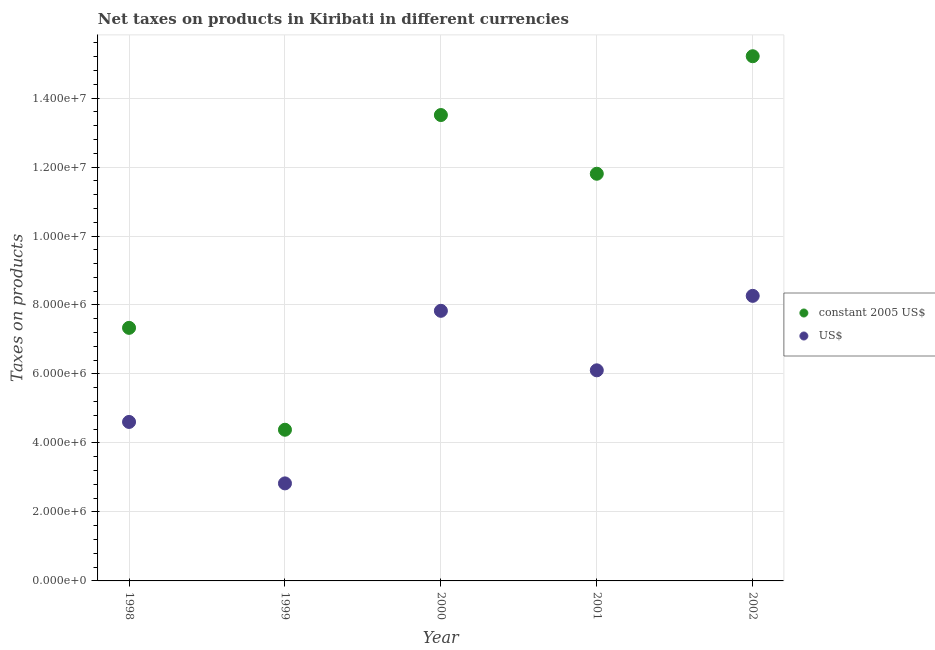How many different coloured dotlines are there?
Your answer should be very brief. 2. Is the number of dotlines equal to the number of legend labels?
Provide a succinct answer. Yes. What is the net taxes in us$ in 2001?
Your answer should be very brief. 6.11e+06. Across all years, what is the maximum net taxes in us$?
Provide a succinct answer. 8.26e+06. Across all years, what is the minimum net taxes in us$?
Offer a very short reply. 2.83e+06. What is the total net taxes in us$ in the graph?
Give a very brief answer. 2.96e+07. What is the difference between the net taxes in constant 2005 us$ in 1998 and that in 2002?
Give a very brief answer. -7.88e+06. What is the difference between the net taxes in us$ in 2001 and the net taxes in constant 2005 us$ in 1999?
Give a very brief answer. 1.72e+06. What is the average net taxes in us$ per year?
Ensure brevity in your answer.  5.93e+06. In the year 2001, what is the difference between the net taxes in us$ and net taxes in constant 2005 us$?
Ensure brevity in your answer.  -5.70e+06. What is the ratio of the net taxes in us$ in 1998 to that in 2000?
Ensure brevity in your answer.  0.59. What is the difference between the highest and the second highest net taxes in constant 2005 us$?
Offer a very short reply. 1.70e+06. What is the difference between the highest and the lowest net taxes in constant 2005 us$?
Offer a very short reply. 1.08e+07. In how many years, is the net taxes in constant 2005 us$ greater than the average net taxes in constant 2005 us$ taken over all years?
Your response must be concise. 3. Is the sum of the net taxes in us$ in 2000 and 2001 greater than the maximum net taxes in constant 2005 us$ across all years?
Make the answer very short. No. Is the net taxes in us$ strictly less than the net taxes in constant 2005 us$ over the years?
Provide a succinct answer. Yes. How many dotlines are there?
Offer a very short reply. 2. What is the difference between two consecutive major ticks on the Y-axis?
Your answer should be compact. 2.00e+06. Are the values on the major ticks of Y-axis written in scientific E-notation?
Keep it short and to the point. Yes. Does the graph contain any zero values?
Your answer should be compact. No. How many legend labels are there?
Your answer should be very brief. 2. How are the legend labels stacked?
Give a very brief answer. Vertical. What is the title of the graph?
Ensure brevity in your answer.  Net taxes on products in Kiribati in different currencies. Does "Forest land" appear as one of the legend labels in the graph?
Offer a terse response. No. What is the label or title of the X-axis?
Give a very brief answer. Year. What is the label or title of the Y-axis?
Your response must be concise. Taxes on products. What is the Taxes on products in constant 2005 US$ in 1998?
Provide a short and direct response. 7.34e+06. What is the Taxes on products of US$ in 1998?
Ensure brevity in your answer.  4.61e+06. What is the Taxes on products of constant 2005 US$ in 1999?
Ensure brevity in your answer.  4.38e+06. What is the Taxes on products of US$ in 1999?
Offer a very short reply. 2.83e+06. What is the Taxes on products in constant 2005 US$ in 2000?
Provide a short and direct response. 1.35e+07. What is the Taxes on products in US$ in 2000?
Your answer should be very brief. 7.83e+06. What is the Taxes on products in constant 2005 US$ in 2001?
Your answer should be compact. 1.18e+07. What is the Taxes on products in US$ in 2001?
Provide a succinct answer. 6.11e+06. What is the Taxes on products in constant 2005 US$ in 2002?
Offer a terse response. 1.52e+07. What is the Taxes on products in US$ in 2002?
Your answer should be very brief. 8.26e+06. Across all years, what is the maximum Taxes on products of constant 2005 US$?
Make the answer very short. 1.52e+07. Across all years, what is the maximum Taxes on products in US$?
Keep it short and to the point. 8.26e+06. Across all years, what is the minimum Taxes on products in constant 2005 US$?
Offer a terse response. 4.38e+06. Across all years, what is the minimum Taxes on products of US$?
Offer a very short reply. 2.83e+06. What is the total Taxes on products in constant 2005 US$ in the graph?
Ensure brevity in your answer.  5.22e+07. What is the total Taxes on products of US$ in the graph?
Make the answer very short. 2.96e+07. What is the difference between the Taxes on products in constant 2005 US$ in 1998 and that in 1999?
Ensure brevity in your answer.  2.95e+06. What is the difference between the Taxes on products in US$ in 1998 and that in 1999?
Offer a terse response. 1.78e+06. What is the difference between the Taxes on products in constant 2005 US$ in 1998 and that in 2000?
Your answer should be very brief. -6.17e+06. What is the difference between the Taxes on products of US$ in 1998 and that in 2000?
Give a very brief answer. -3.22e+06. What is the difference between the Taxes on products in constant 2005 US$ in 1998 and that in 2001?
Offer a very short reply. -4.47e+06. What is the difference between the Taxes on products of US$ in 1998 and that in 2001?
Your response must be concise. -1.50e+06. What is the difference between the Taxes on products in constant 2005 US$ in 1998 and that in 2002?
Ensure brevity in your answer.  -7.88e+06. What is the difference between the Taxes on products in US$ in 1998 and that in 2002?
Provide a short and direct response. -3.66e+06. What is the difference between the Taxes on products of constant 2005 US$ in 1999 and that in 2000?
Your answer should be very brief. -9.12e+06. What is the difference between the Taxes on products in US$ in 1999 and that in 2000?
Make the answer very short. -5.00e+06. What is the difference between the Taxes on products of constant 2005 US$ in 1999 and that in 2001?
Your answer should be compact. -7.42e+06. What is the difference between the Taxes on products of US$ in 1999 and that in 2001?
Make the answer very short. -3.28e+06. What is the difference between the Taxes on products in constant 2005 US$ in 1999 and that in 2002?
Your answer should be compact. -1.08e+07. What is the difference between the Taxes on products of US$ in 1999 and that in 2002?
Offer a very short reply. -5.44e+06. What is the difference between the Taxes on products in constant 2005 US$ in 2000 and that in 2001?
Provide a succinct answer. 1.70e+06. What is the difference between the Taxes on products in US$ in 2000 and that in 2001?
Provide a short and direct response. 1.73e+06. What is the difference between the Taxes on products in constant 2005 US$ in 2000 and that in 2002?
Offer a terse response. -1.70e+06. What is the difference between the Taxes on products of US$ in 2000 and that in 2002?
Your answer should be very brief. -4.34e+05. What is the difference between the Taxes on products in constant 2005 US$ in 2001 and that in 2002?
Give a very brief answer. -3.41e+06. What is the difference between the Taxes on products of US$ in 2001 and that in 2002?
Offer a very short reply. -2.16e+06. What is the difference between the Taxes on products of constant 2005 US$ in 1998 and the Taxes on products of US$ in 1999?
Your answer should be compact. 4.51e+06. What is the difference between the Taxes on products in constant 2005 US$ in 1998 and the Taxes on products in US$ in 2000?
Offer a very short reply. -4.94e+05. What is the difference between the Taxes on products of constant 2005 US$ in 1998 and the Taxes on products of US$ in 2001?
Give a very brief answer. 1.23e+06. What is the difference between the Taxes on products in constant 2005 US$ in 1998 and the Taxes on products in US$ in 2002?
Your answer should be very brief. -9.28e+05. What is the difference between the Taxes on products of constant 2005 US$ in 1999 and the Taxes on products of US$ in 2000?
Your answer should be compact. -3.45e+06. What is the difference between the Taxes on products in constant 2005 US$ in 1999 and the Taxes on products in US$ in 2001?
Make the answer very short. -1.72e+06. What is the difference between the Taxes on products in constant 2005 US$ in 1999 and the Taxes on products in US$ in 2002?
Your response must be concise. -3.88e+06. What is the difference between the Taxes on products in constant 2005 US$ in 2000 and the Taxes on products in US$ in 2001?
Offer a terse response. 7.40e+06. What is the difference between the Taxes on products in constant 2005 US$ in 2000 and the Taxes on products in US$ in 2002?
Make the answer very short. 5.24e+06. What is the difference between the Taxes on products in constant 2005 US$ in 2001 and the Taxes on products in US$ in 2002?
Your answer should be compact. 3.54e+06. What is the average Taxes on products in constant 2005 US$ per year?
Keep it short and to the point. 1.04e+07. What is the average Taxes on products of US$ per year?
Your answer should be very brief. 5.93e+06. In the year 1998, what is the difference between the Taxes on products in constant 2005 US$ and Taxes on products in US$?
Offer a terse response. 2.73e+06. In the year 1999, what is the difference between the Taxes on products of constant 2005 US$ and Taxes on products of US$?
Give a very brief answer. 1.56e+06. In the year 2000, what is the difference between the Taxes on products of constant 2005 US$ and Taxes on products of US$?
Offer a terse response. 5.68e+06. In the year 2001, what is the difference between the Taxes on products of constant 2005 US$ and Taxes on products of US$?
Your response must be concise. 5.70e+06. In the year 2002, what is the difference between the Taxes on products of constant 2005 US$ and Taxes on products of US$?
Make the answer very short. 6.95e+06. What is the ratio of the Taxes on products in constant 2005 US$ in 1998 to that in 1999?
Ensure brevity in your answer.  1.67. What is the ratio of the Taxes on products of US$ in 1998 to that in 1999?
Offer a terse response. 1.63. What is the ratio of the Taxes on products in constant 2005 US$ in 1998 to that in 2000?
Your answer should be very brief. 0.54. What is the ratio of the Taxes on products in US$ in 1998 to that in 2000?
Keep it short and to the point. 0.59. What is the ratio of the Taxes on products in constant 2005 US$ in 1998 to that in 2001?
Give a very brief answer. 0.62. What is the ratio of the Taxes on products in US$ in 1998 to that in 2001?
Keep it short and to the point. 0.75. What is the ratio of the Taxes on products in constant 2005 US$ in 1998 to that in 2002?
Your answer should be very brief. 0.48. What is the ratio of the Taxes on products in US$ in 1998 to that in 2002?
Your answer should be compact. 0.56. What is the ratio of the Taxes on products in constant 2005 US$ in 1999 to that in 2000?
Your response must be concise. 0.32. What is the ratio of the Taxes on products of US$ in 1999 to that in 2000?
Provide a succinct answer. 0.36. What is the ratio of the Taxes on products of constant 2005 US$ in 1999 to that in 2001?
Ensure brevity in your answer.  0.37. What is the ratio of the Taxes on products of US$ in 1999 to that in 2001?
Offer a very short reply. 0.46. What is the ratio of the Taxes on products of constant 2005 US$ in 1999 to that in 2002?
Provide a short and direct response. 0.29. What is the ratio of the Taxes on products of US$ in 1999 to that in 2002?
Provide a succinct answer. 0.34. What is the ratio of the Taxes on products of constant 2005 US$ in 2000 to that in 2001?
Offer a terse response. 1.14. What is the ratio of the Taxes on products of US$ in 2000 to that in 2001?
Your answer should be very brief. 1.28. What is the ratio of the Taxes on products of constant 2005 US$ in 2000 to that in 2002?
Provide a short and direct response. 0.89. What is the ratio of the Taxes on products in US$ in 2000 to that in 2002?
Provide a short and direct response. 0.95. What is the ratio of the Taxes on products in constant 2005 US$ in 2001 to that in 2002?
Keep it short and to the point. 0.78. What is the ratio of the Taxes on products in US$ in 2001 to that in 2002?
Ensure brevity in your answer.  0.74. What is the difference between the highest and the second highest Taxes on products of constant 2005 US$?
Provide a short and direct response. 1.70e+06. What is the difference between the highest and the second highest Taxes on products of US$?
Ensure brevity in your answer.  4.34e+05. What is the difference between the highest and the lowest Taxes on products of constant 2005 US$?
Offer a very short reply. 1.08e+07. What is the difference between the highest and the lowest Taxes on products of US$?
Your response must be concise. 5.44e+06. 